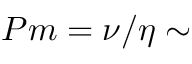<formula> <loc_0><loc_0><loc_500><loc_500>P m = \nu / \eta \sim</formula> 